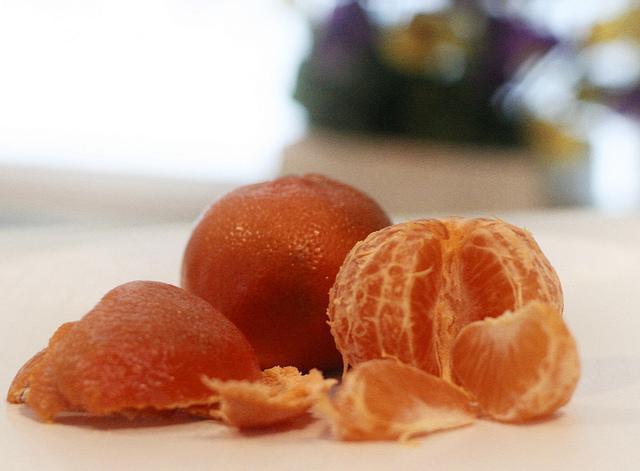How many slices are out of the orange?
Give a very brief answer. 2. How many people are eating?
Give a very brief answer. 0. How many oranges are there?
Give a very brief answer. 3. 